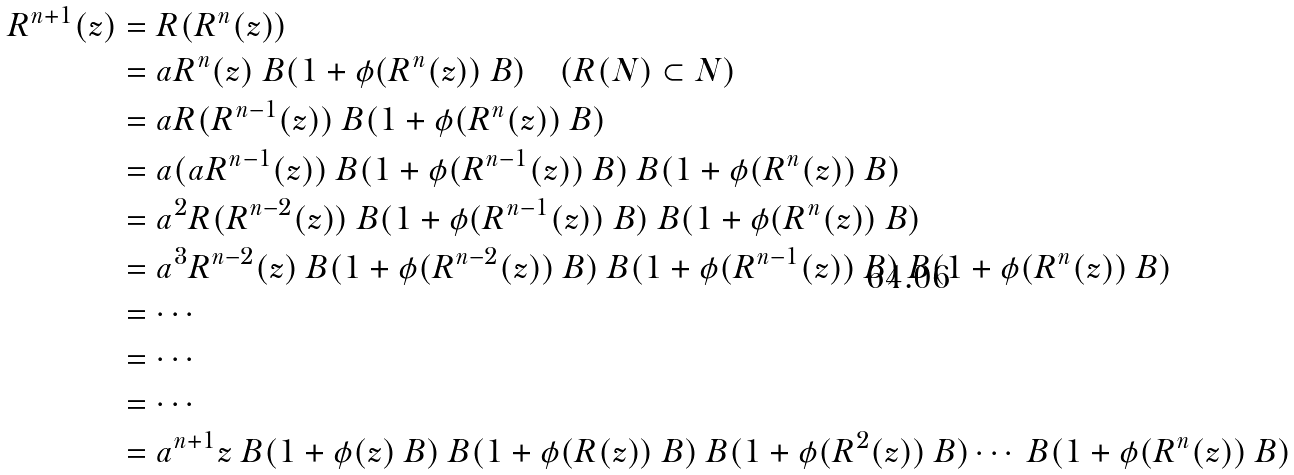<formula> <loc_0><loc_0><loc_500><loc_500>R ^ { n + 1 } ( z ) & = R ( R ^ { n } ( z ) ) \\ & = a R ^ { n } ( z ) \ B ( 1 + \phi ( R ^ { n } ( z ) ) \ B ) \quad ( R ( N ) \subset N ) \\ & = a R ( R ^ { n - 1 } ( z ) ) \ B ( 1 + \phi ( R ^ { n } ( z ) ) \ B ) \\ & = a ( a R ^ { n - 1 } ( z ) ) \ B ( 1 + \phi ( R ^ { n - 1 } ( z ) ) \ B ) \ B ( 1 + \phi ( R ^ { n } ( z ) ) \ B ) \\ & = a ^ { 2 } R ( R ^ { n - 2 } ( z ) ) \ B ( 1 + \phi ( R ^ { n - 1 } ( z ) ) \ B ) \ B ( 1 + \phi ( R ^ { n } ( z ) ) \ B ) \\ & = a ^ { 3 } R ^ { n - 2 } ( z ) \ B ( 1 + \phi ( R ^ { n - 2 } ( z ) ) \ B ) \ B ( 1 + \phi ( R ^ { n - 1 } ( z ) ) \ B ) \ B ( 1 + \phi ( R ^ { n } ( z ) ) \ B ) \\ & = \cdots \\ & = \cdots \\ & = \cdots \\ & = a ^ { n + 1 } z \ B ( 1 + \phi ( z ) \ B ) \ B ( 1 + \phi ( R ( z ) ) \ B ) \ B ( 1 + \phi ( R ^ { 2 } ( z ) ) \ B ) \cdots \ B ( 1 + \phi ( R ^ { n } ( z ) ) \ B )</formula> 